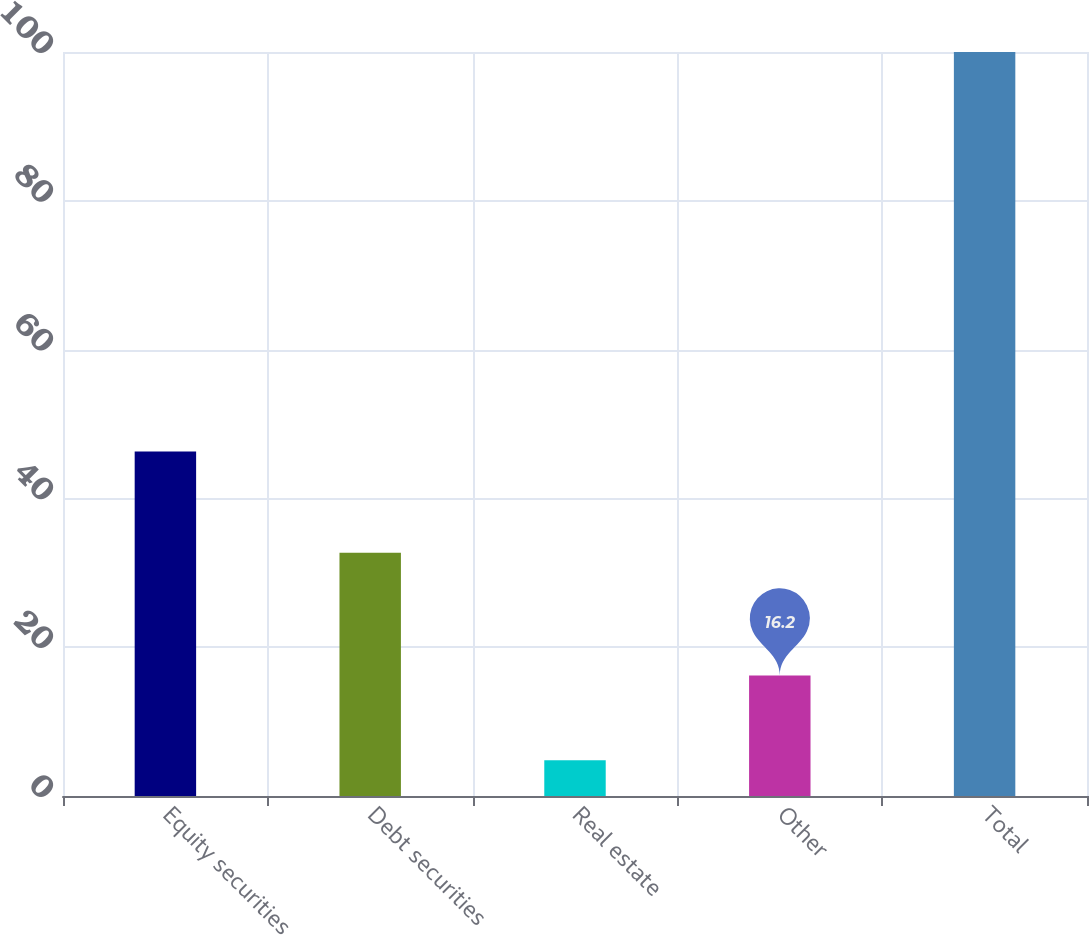<chart> <loc_0><loc_0><loc_500><loc_500><bar_chart><fcel>Equity securities<fcel>Debt securities<fcel>Real estate<fcel>Other<fcel>Total<nl><fcel>46.3<fcel>32.7<fcel>4.8<fcel>16.2<fcel>100<nl></chart> 